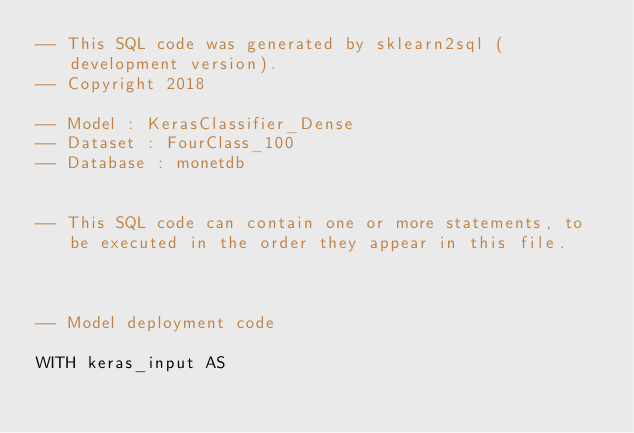<code> <loc_0><loc_0><loc_500><loc_500><_SQL_>-- This SQL code was generated by sklearn2sql (development version).
-- Copyright 2018

-- Model : KerasClassifier_Dense
-- Dataset : FourClass_100
-- Database : monetdb


-- This SQL code can contain one or more statements, to be executed in the order they appear in this file.



-- Model deployment code

WITH keras_input AS </code> 